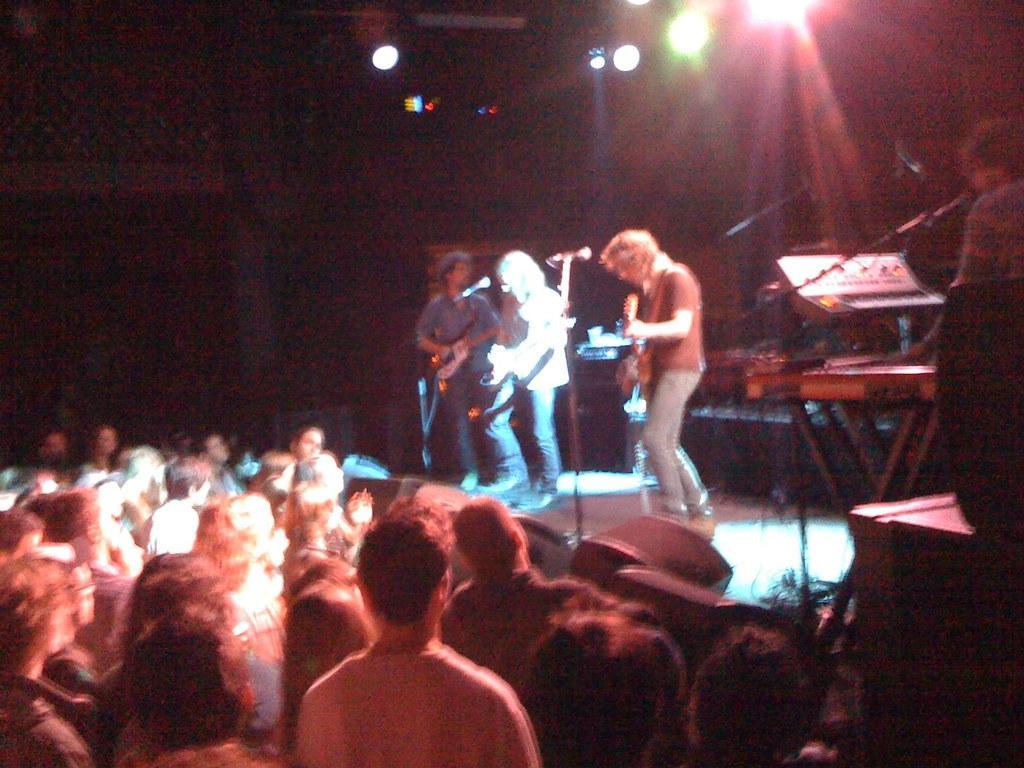Please provide a concise description of this image. Here we can see a group of people are standing on the stage, and playing the musical instruments, and in front here is the microphone and stand, and here a person is playing the piano, and here are the lights, and here the group of people are standing. 